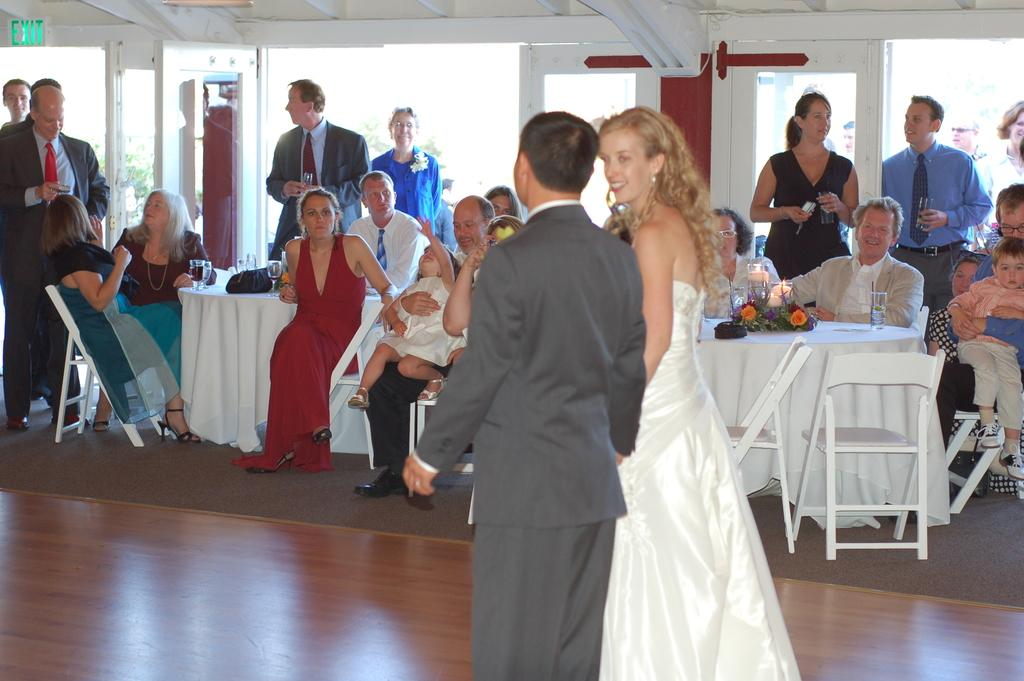What are the main subjects in the image? There is a couple walking in the image. What objects can be seen in the image? There are chairs in the image. What is happening in the background of the image? In the background, there are people sitting and standing. What are the people in the background doing? The people in the background are looking at the couple. What type of hammer is being used by the couple in the image? There is no hammer present in the image; the couple is simply walking. How long has the couple been walking for in the image? The image does not provide information about the duration of the couple's walk. 